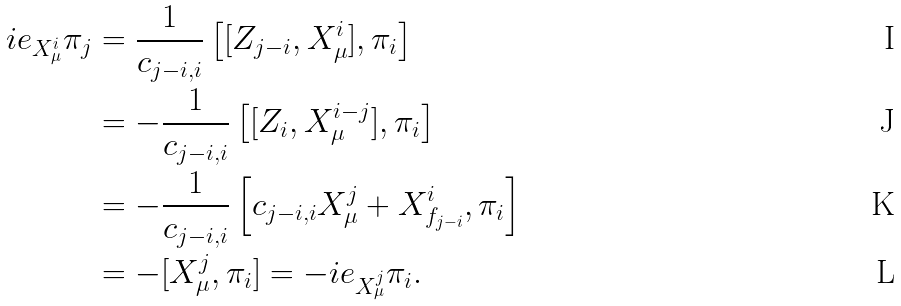Convert formula to latex. <formula><loc_0><loc_0><loc_500><loc_500>\L i e _ { X ^ { i } _ { \mu } } \pi _ { j } & = \frac { 1 } { c _ { j - i , i } } \left [ [ Z _ { j - i } , X ^ { i } _ { \mu } ] , \pi _ { i } \right ] \\ & = - \frac { 1 } { c _ { j - i , i } } \left [ [ Z _ { i } , X ^ { i - j } _ { \mu } ] , \pi _ { i } \right ] \\ & = - \frac { 1 } { c _ { j - i , i } } \left [ c _ { j - i , i } X ^ { j } _ { \mu } + X _ { f _ { j - i } } ^ { i } , \pi _ { i } \right ] \\ & = - [ X ^ { j } _ { \mu } , \pi _ { i } ] = - \L i e _ { X ^ { j } _ { \mu } } \pi _ { i } .</formula> 